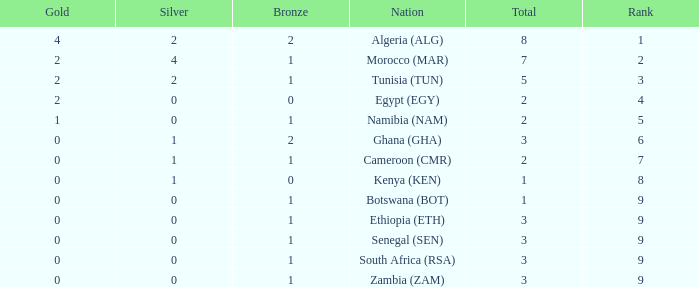What is the lowest Bronze with a Nation of egypt (egy) and with a Gold that is smaller than 2? None. 